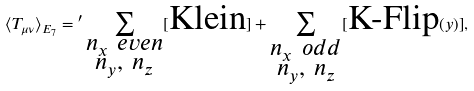<formula> <loc_0><loc_0><loc_500><loc_500>\langle T _ { \mu \nu } \rangle _ { E _ { 7 } } = { ^ { \prime } } \sum _ { \substack { n _ { x } \ e v e n \\ n _ { y } , \ n _ { z } } } [ \text {Klein} ] + \sum _ { \substack { n _ { x } \ o d d \\ n _ { y } , \ n _ { z } } } [ \text {K-Flip} ( y ) ] ,</formula> 